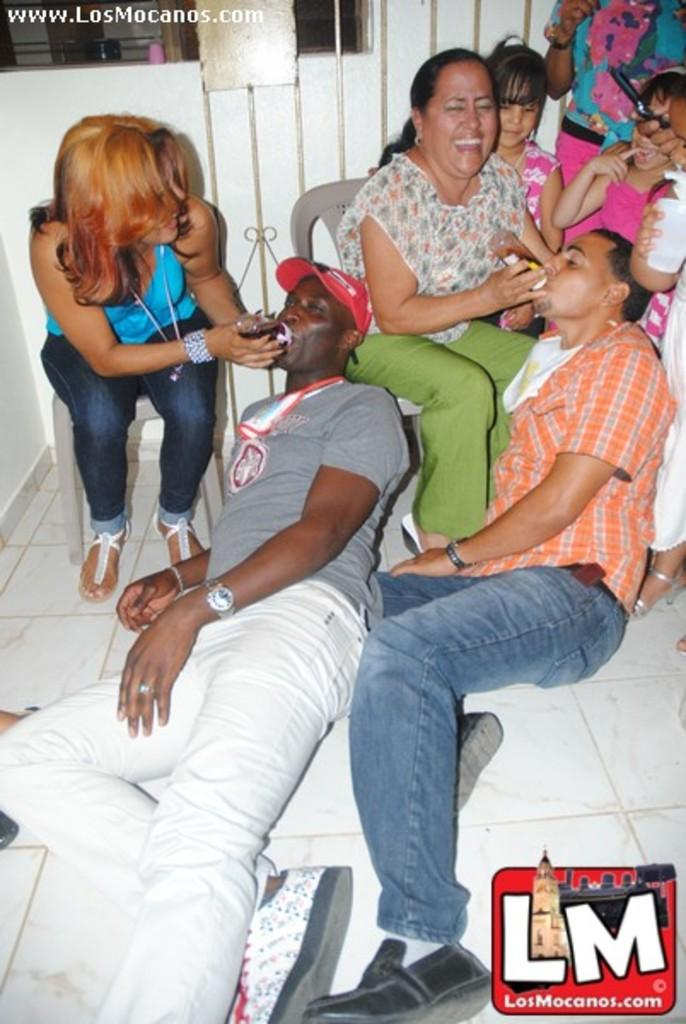How many people are in the group in the image? There is a group of people in the image, but the exact number is not specified. What are some of the people in the group doing? Some people in the group are sitting, while others are standing. Can you describe the positions of the people in the group? The people in the group are either sitting or standing, but their specific positions are not detailed. What color is the paint on the chessboard in the image? There is no chessboard or paint present in the image. What type of rod is being used by the people in the image? There is no rod present in the image. 